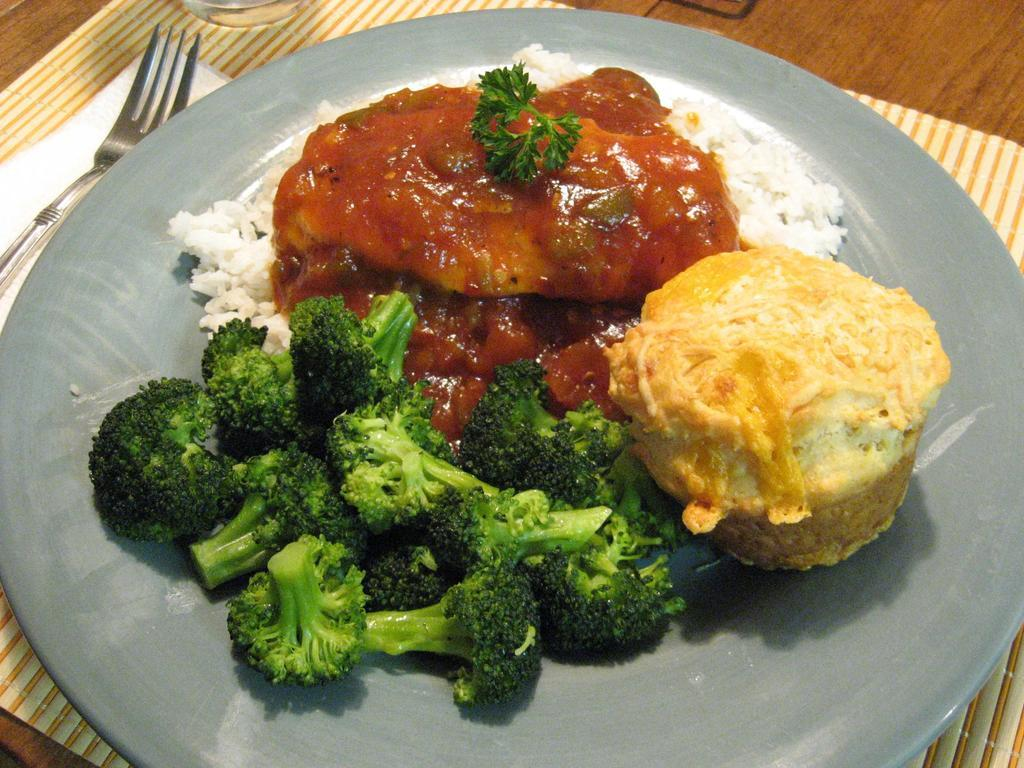What is on the plate that is visible in the image? There is food on a plate in the image. What is the plate used for in the image? The plate is used for holding food in the image. What is the glass used for in the image? The glass is used for holding a beverage in the image. What is the fork used for in the image? The fork is used for eating the food in the image. What is the tissue used for in the image? The tissue is used for wiping or cleaning in the image. What is the table mat used for in the image? The table mat is used for protecting the table surface in the image. Who is the creator of the food in the image? The text does not provide information about the creator of the food in the image. What is the daughter doing in the image? There is no mention of a daughter in the text, so we cannot answer this question. 